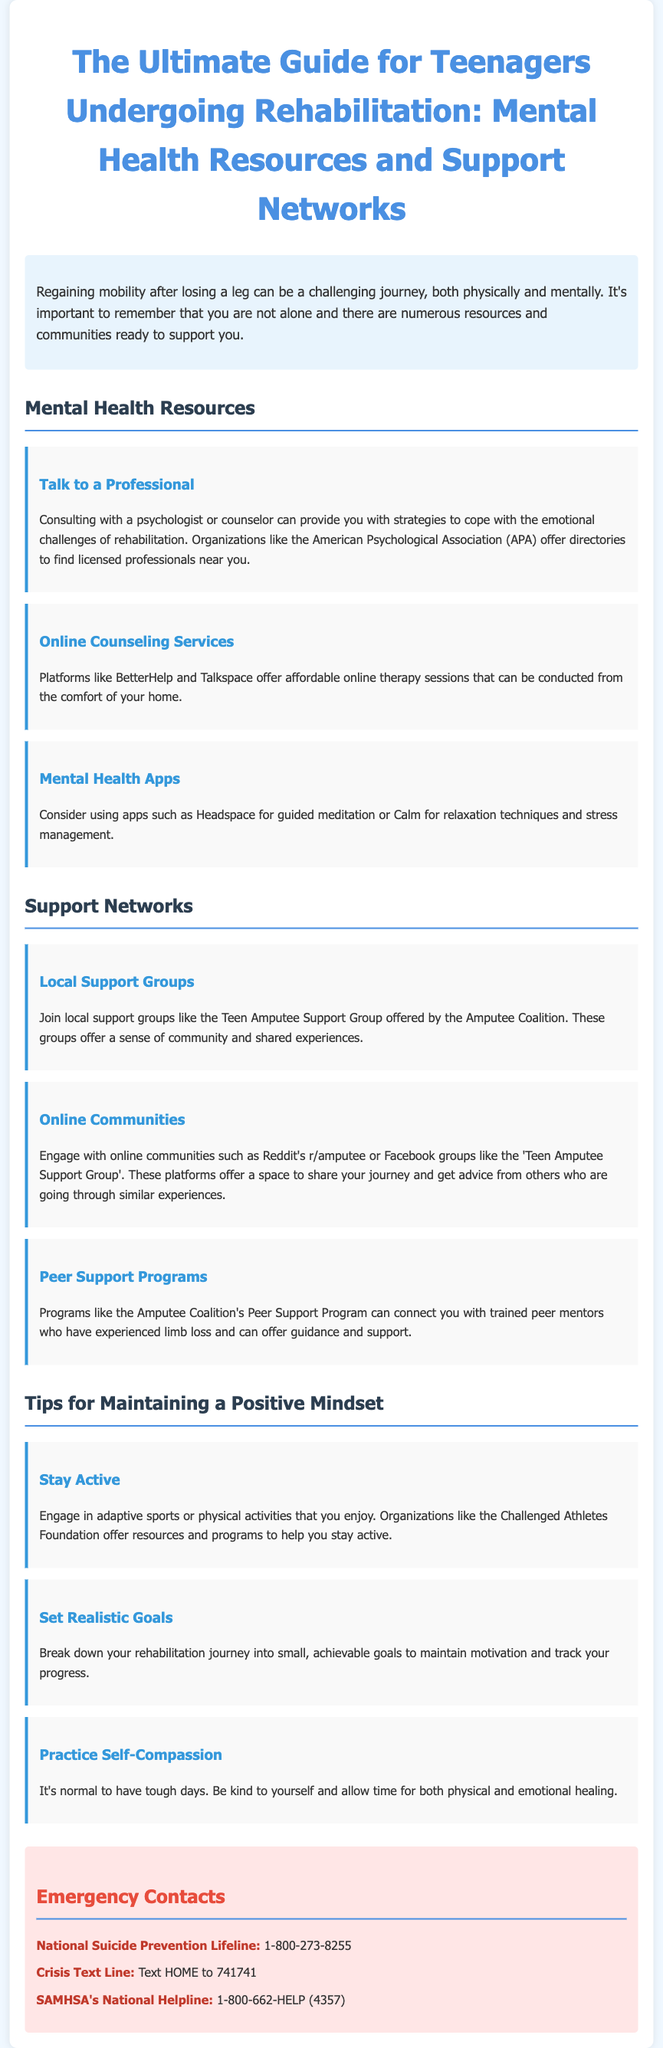What is the title of the guide? The title provides the main subject of the document which is aimed at teenagers undergoing rehabilitation.
Answer: The Ultimate Guide for Teenagers Undergoing Rehabilitation: Mental Health Resources and Support Which organization offers a directory of licensed professionals? The document mentions a specific organization that helps individuals find psychologists or counselors.
Answer: American Psychological Association What is one of the online counseling services mentioned? The document lists various online platforms that provide therapy, asking for a specific example.
Answer: BetterHelp What is a suggested app for relaxation techniques? The document recommends specific apps that can help with relaxation, asking for one of them.
Answer: Calm How can you engage with online communities? The document explains how teenagers can connect with others undergoing similar experiences.
Answer: Reddit's r/amputee What is the main purpose of setting realistic goals? The document suggests breaking down rehabilitation into smaller goals, asking for the reasoning behind this practice.
Answer: To maintain motivation Which support group is mentioned for teenagers? The document identifies a specific local support group that caters to young individuals dealing with limb loss.
Answer: Teen Amputee Support Group What should you text to reach the Crisis Text Line? The document provides a specific action to take to utilize this resource for crisis support.
Answer: HOME 